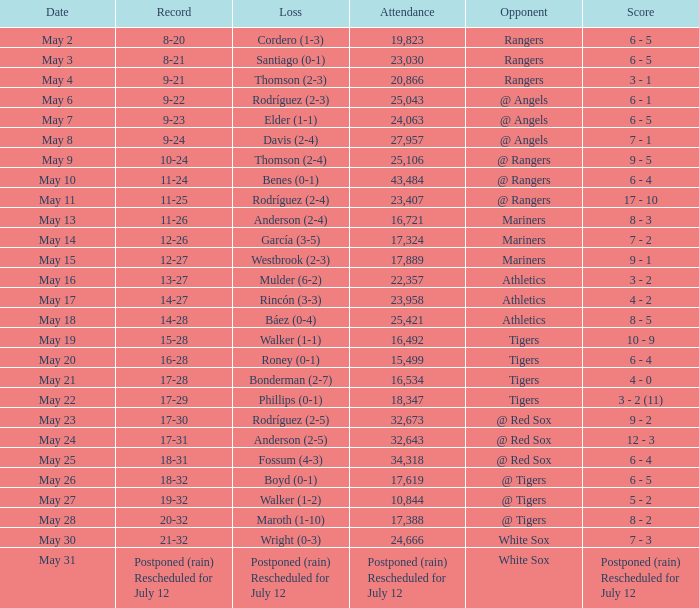What was the Indians record during the game that had 19,823 fans attending? 8-20. 